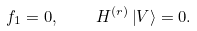Convert formula to latex. <formula><loc_0><loc_0><loc_500><loc_500>f _ { 1 } = 0 , \quad H ^ { ( r ) } \left | V \right \rangle = 0 .</formula> 